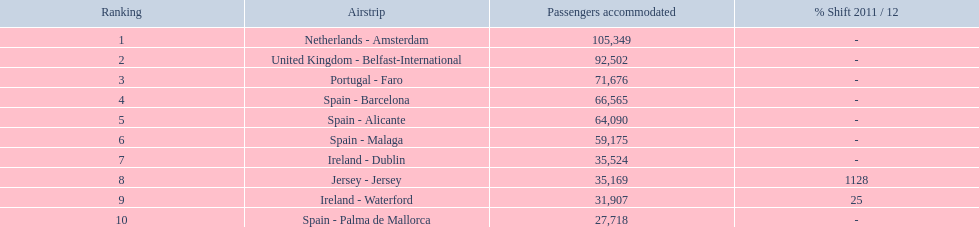What are the names of all the airports? Netherlands - Amsterdam, United Kingdom - Belfast-International, Portugal - Faro, Spain - Barcelona, Spain - Alicante, Spain - Malaga, Ireland - Dublin, Jersey - Jersey, Ireland - Waterford, Spain - Palma de Mallorca. Of these, what are all the passenger counts? 105,349, 92,502, 71,676, 66,565, 64,090, 59,175, 35,524, 35,169, 31,907, 27,718. Of these, which airport had more passengers than the united kingdom? Netherlands - Amsterdam. 